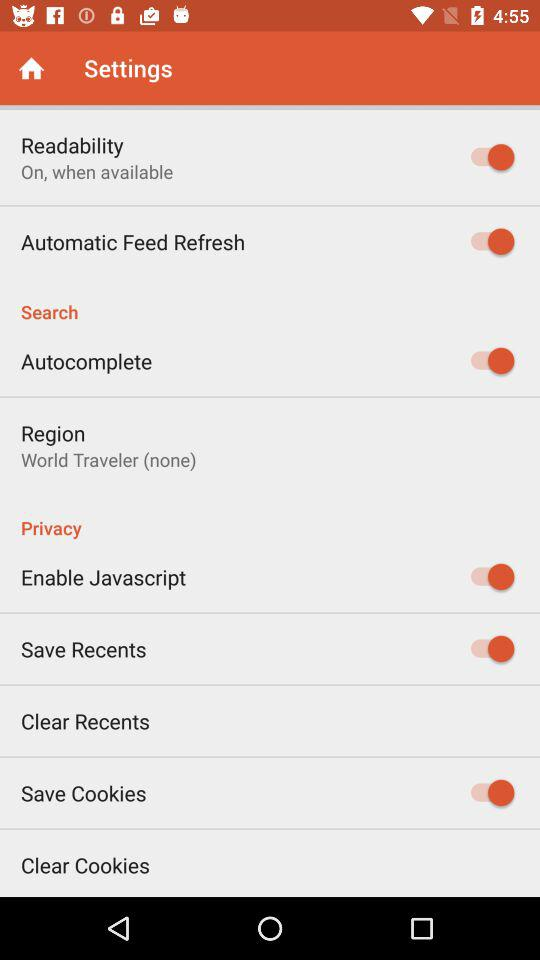What is the status of "Autocomplete"? The status is "on". 